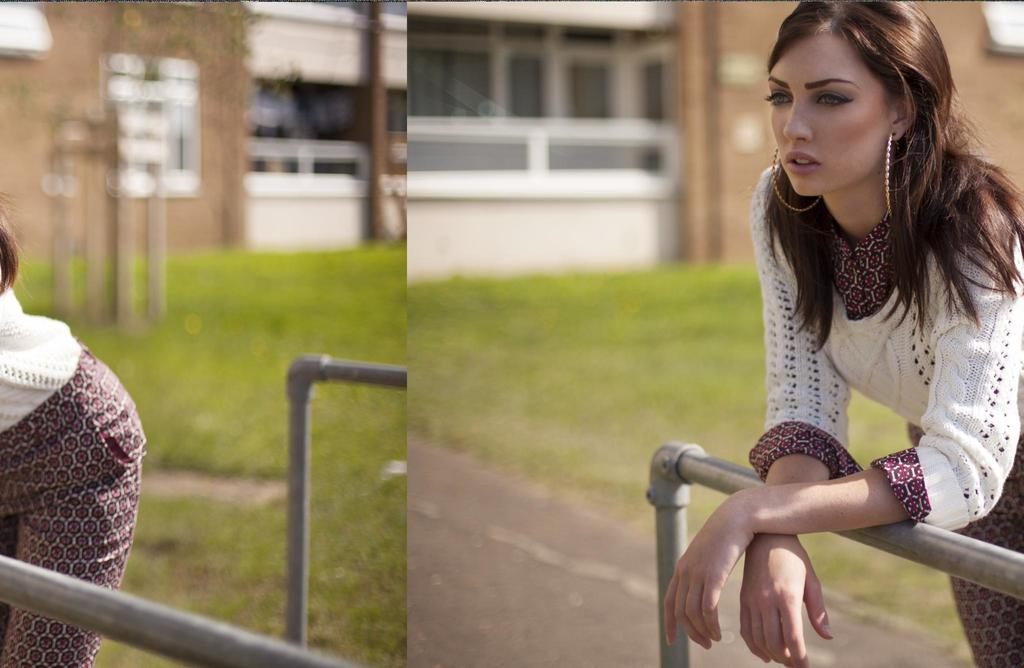What type of artwork is the image? The image is a collage. Who or what can be seen in the image? There is a woman in the image. What type of natural environment is depicted in the image? There is grass in the image. What man-made structures are present in the image? There are rods and a building in the image. Can you see any dirt on the woman's shoes in the image? There is no information about the woman's shoes or any dirt on them in the image. 